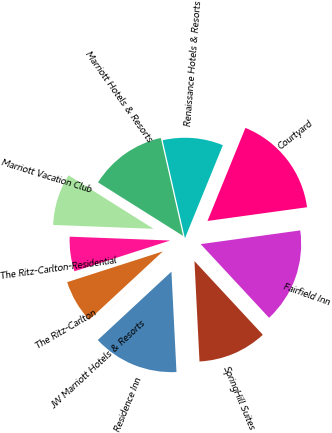Convert chart to OTSL. <chart><loc_0><loc_0><loc_500><loc_500><pie_chart><fcel>Marriott Hotels & Resorts<fcel>Renaissance Hotels & Resorts<fcel>Courtyard<fcel>Fairfield Inn<fcel>SpringHill Suites<fcel>Residence Inn<fcel>JW Marriott Hotels & Resorts<fcel>The Ritz-Carlton<fcel>The Ritz-Carlton-Residential<fcel>Marriott Vacation Club<nl><fcel>12.5%<fcel>9.72%<fcel>16.66%<fcel>15.27%<fcel>11.11%<fcel>13.89%<fcel>0.01%<fcel>6.95%<fcel>5.56%<fcel>8.33%<nl></chart> 